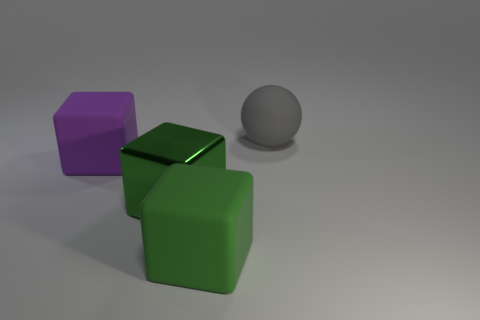Add 1 large gray metal spheres. How many objects exist? 5 Subtract all spheres. How many objects are left? 3 Subtract all small metal things. Subtract all big balls. How many objects are left? 3 Add 3 green metal blocks. How many green metal blocks are left? 4 Add 2 green matte things. How many green matte things exist? 3 Subtract 1 gray balls. How many objects are left? 3 